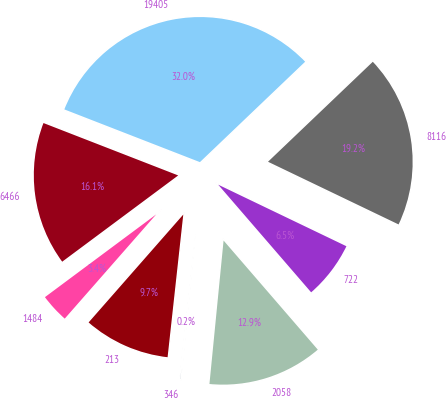Convert chart to OTSL. <chart><loc_0><loc_0><loc_500><loc_500><pie_chart><fcel>6466<fcel>1484<fcel>213<fcel>346<fcel>2058<fcel>722<fcel>8116<fcel>19405<nl><fcel>16.08%<fcel>3.36%<fcel>9.72%<fcel>0.18%<fcel>12.9%<fcel>6.54%<fcel>19.25%<fcel>31.97%<nl></chart> 